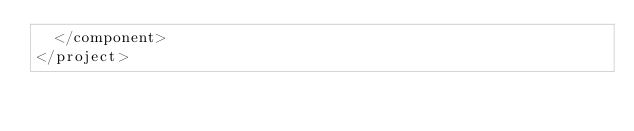<code> <loc_0><loc_0><loc_500><loc_500><_XML_>  </component>
</project></code> 